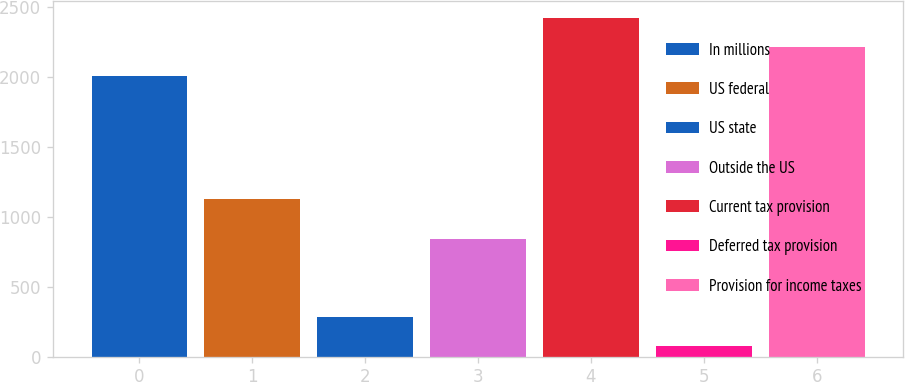Convert chart. <chart><loc_0><loc_0><loc_500><loc_500><bar_chart><fcel>In millions<fcel>US federal<fcel>US state<fcel>Outside the US<fcel>Current tax provision<fcel>Deferred tax provision<fcel>Provision for income taxes<nl><fcel>2010<fcel>1127.1<fcel>281.1<fcel>841.5<fcel>2420.8<fcel>75.7<fcel>2215.4<nl></chart> 